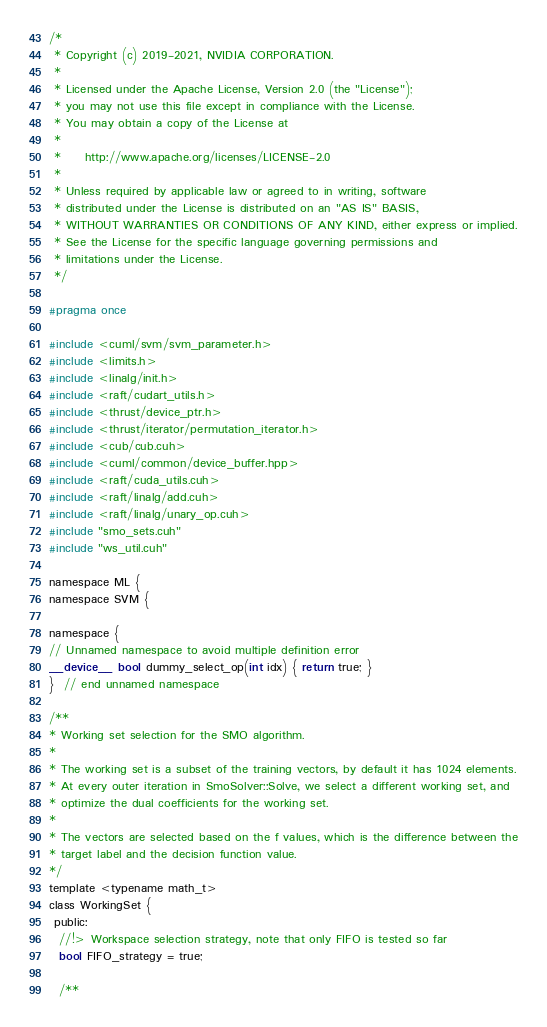Convert code to text. <code><loc_0><loc_0><loc_500><loc_500><_Cuda_>/*
 * Copyright (c) 2019-2021, NVIDIA CORPORATION.
 *
 * Licensed under the Apache License, Version 2.0 (the "License");
 * you may not use this file except in compliance with the License.
 * You may obtain a copy of the License at
 *
 *     http://www.apache.org/licenses/LICENSE-2.0
 *
 * Unless required by applicable law or agreed to in writing, software
 * distributed under the License is distributed on an "AS IS" BASIS,
 * WITHOUT WARRANTIES OR CONDITIONS OF ANY KIND, either express or implied.
 * See the License for the specific language governing permissions and
 * limitations under the License.
 */

#pragma once

#include <cuml/svm/svm_parameter.h>
#include <limits.h>
#include <linalg/init.h>
#include <raft/cudart_utils.h>
#include <thrust/device_ptr.h>
#include <thrust/iterator/permutation_iterator.h>
#include <cub/cub.cuh>
#include <cuml/common/device_buffer.hpp>
#include <raft/cuda_utils.cuh>
#include <raft/linalg/add.cuh>
#include <raft/linalg/unary_op.cuh>
#include "smo_sets.cuh"
#include "ws_util.cuh"

namespace ML {
namespace SVM {

namespace {
// Unnamed namespace to avoid multiple definition error
__device__ bool dummy_select_op(int idx) { return true; }
}  // end unnamed namespace

/**
* Working set selection for the SMO algorithm.
*
* The working set is a subset of the training vectors, by default it has 1024 elements.
* At every outer iteration in SmoSolver::Solve, we select a different working set, and
* optimize the dual coefficients for the working set.
*
* The vectors are selected based on the f values, which is the difference between the
* target label and the decision function value.
*/
template <typename math_t>
class WorkingSet {
 public:
  //!> Workspace selection strategy, note that only FIFO is tested so far
  bool FIFO_strategy = true;

  /**</code> 